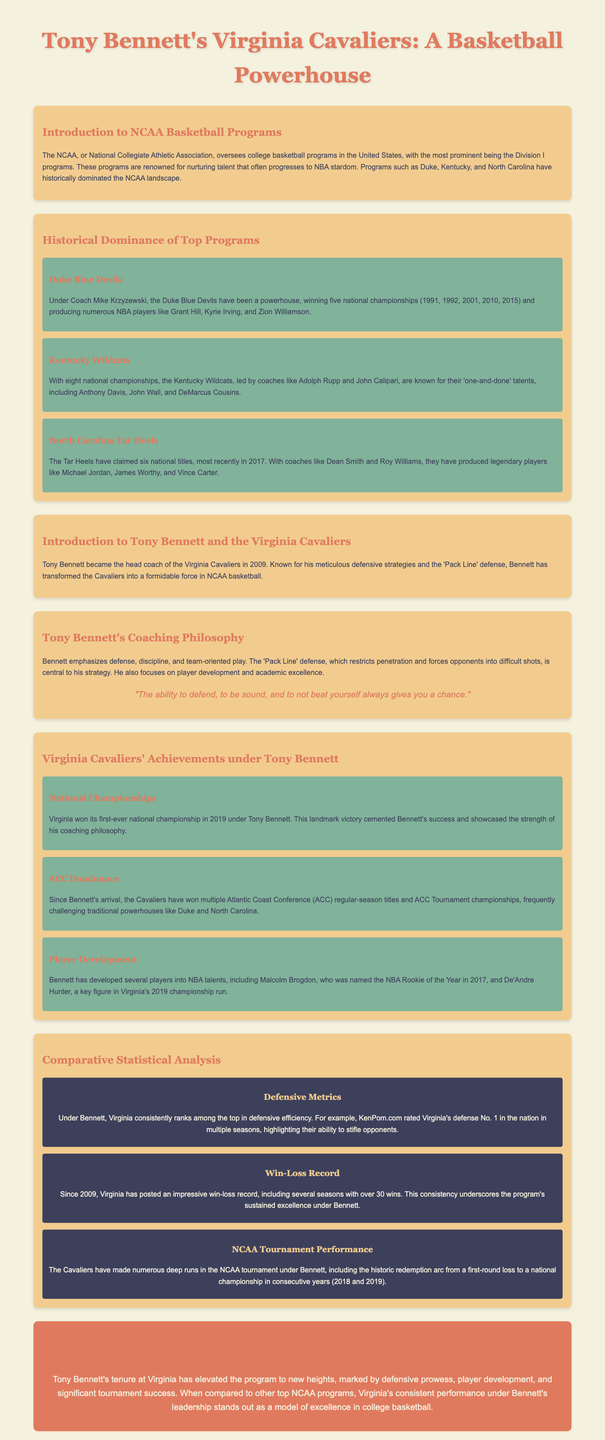what year did Virginia win its first national championship under Tony Bennett? The document states that Virginia won its first-ever national championship in 2019 under Tony Bennett.
Answer: 2019 how many national championships have the Kentucky Wildcats won? The Kentucky Wildcats have won eight national championships, as noted in the historical dominance section.
Answer: eight who was named NBA Rookie of the Year in 2017 from Virginia? Malcolm Brogdon, developed under Tony Bennett, was named NBA Rookie of the Year in 2017.
Answer: Malcolm Brogdon what defensive strategy is central to Tony Bennett's coaching philosophy? The document mentions that the 'Pack Line' defense is central to Tony Bennett's coaching strategy.
Answer: Pack Line defense how many national championships has Duke won under Coach Mike Krzyzewski? The document notes that Duke has won five national championships under Coach Mike Krzyzewski.
Answer: five what is a significant achievement of the Virginia Cavaliers under Tony Bennett in terms of NCAA tournament performance? The Cavaliers had a historic redemption arc, going from a first-round loss to a national championship in consecutive years.
Answer: redemption arc which university produced Michael Jordan according to the infographic? The document states that the North Carolina Tar Heels produced Michael Jordan.
Answer: North Carolina in what year did Tony Bennett become the head coach of the Virginia Cavaliers? The infographic mentions that Tony Bennett became head coach in 2009.
Answer: 2009 